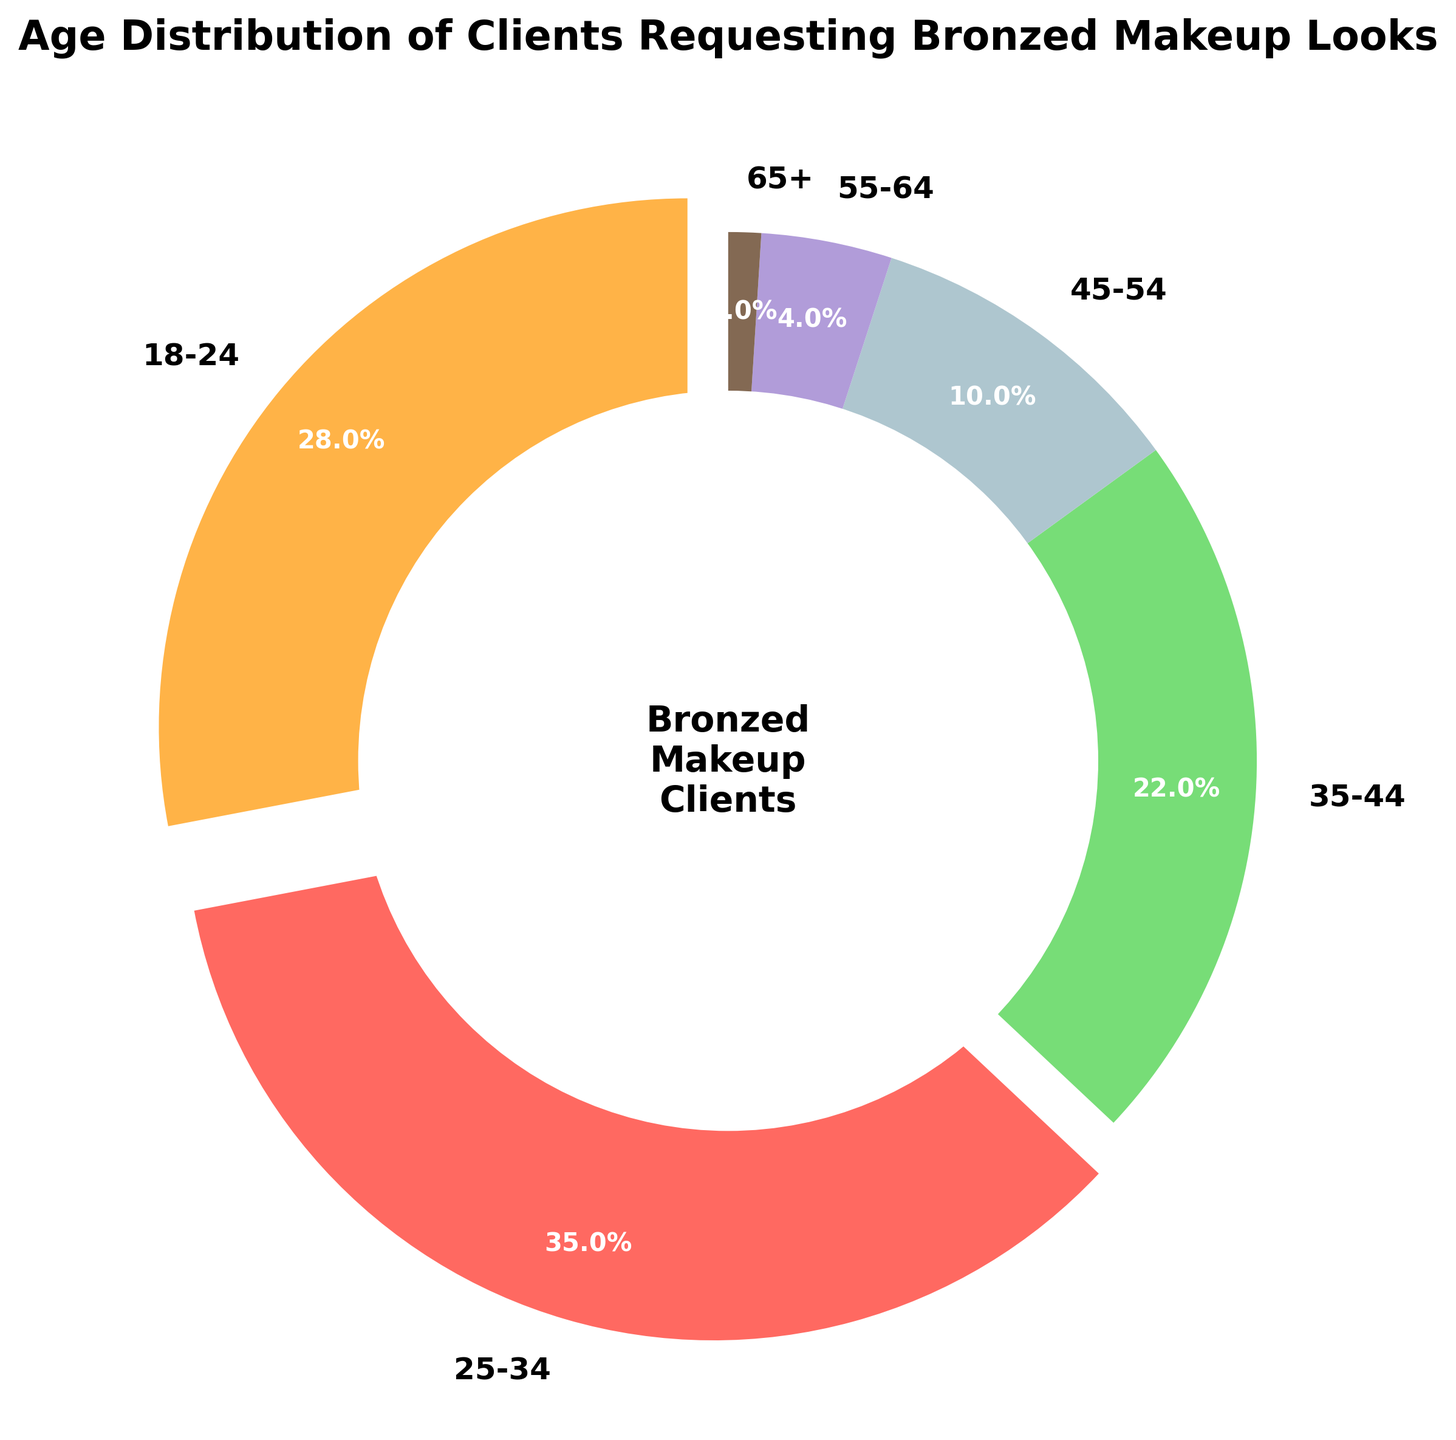Which age group has the highest percentage of clients requesting bronzed makeup looks? Examine the percentages associated with each age group on the pie chart. Identify the one with the highest value.
Answer: 25-34 Which age group has the smallest percentage of clients requesting bronzed makeup looks? Look for the slice of the pie chart that has the smallest proportion and check the corresponding age group.
Answer: 65+ What is the combined percentage of clients aged 18-24 and 25-34? Add the percentages for the 18-24 and 25-34 age groups (28% + 35% = 63%).
Answer: 63% How does the percentage of clients aged 35-44 compare to those aged 45-54? Subtract the percentage of the 45-54 age group from that of the 35-44 age group (22% - 10% = 12%).
Answer: 12% higher What is the total percentage of clients who are 45 years old and above? Sum the percentages for the 45-54, 55-64, and 65+ age groups (10% + 4% + 1% = 15%).
Answer: 15% What color represents the age group 18-24? Examine the pie chart's segments and identify the color that corresponds to the 18-24 age group.
Answer: Orange Which two age groups have the widest and narrowest slices respectively? Look at the pie chart and compare the width and size of the slices, noting which are the widest and narrowest.
Answer: Widest: 25-34, Narrowest: 65+ If we group all clients aged under 35 together, what percentage would they represent? Add the percentages for the 18-24 and 25-34 age groups (28% + 35% = 63%).
Answer: 63% If another age group is added with a percentage of 5%, how would that affect the age group with the current smallest percentage? Compare the new group's percentage to the existing percentages, especially the smallest one at 1%, which would no longer be the smallest.
Answer: The 65+ group would no longer have the smallest percentage 